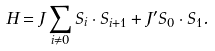Convert formula to latex. <formula><loc_0><loc_0><loc_500><loc_500>H = J \sum _ { i \neq 0 } { S } _ { i } \cdot { S } _ { i + 1 } + J ^ { \prime } { S } _ { 0 } \cdot { S } _ { 1 } .</formula> 